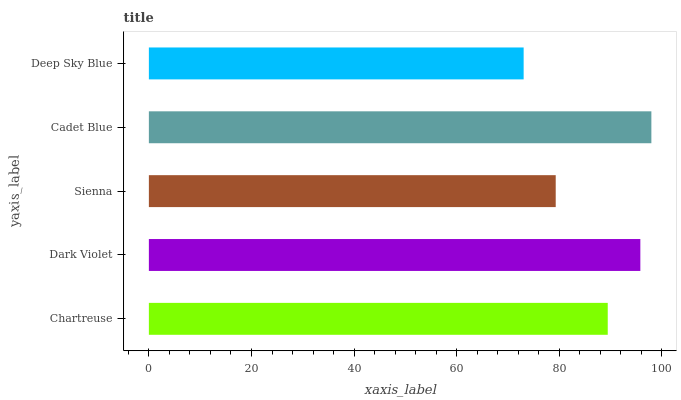Is Deep Sky Blue the minimum?
Answer yes or no. Yes. Is Cadet Blue the maximum?
Answer yes or no. Yes. Is Dark Violet the minimum?
Answer yes or no. No. Is Dark Violet the maximum?
Answer yes or no. No. Is Dark Violet greater than Chartreuse?
Answer yes or no. Yes. Is Chartreuse less than Dark Violet?
Answer yes or no. Yes. Is Chartreuse greater than Dark Violet?
Answer yes or no. No. Is Dark Violet less than Chartreuse?
Answer yes or no. No. Is Chartreuse the high median?
Answer yes or no. Yes. Is Chartreuse the low median?
Answer yes or no. Yes. Is Deep Sky Blue the high median?
Answer yes or no. No. Is Sienna the low median?
Answer yes or no. No. 